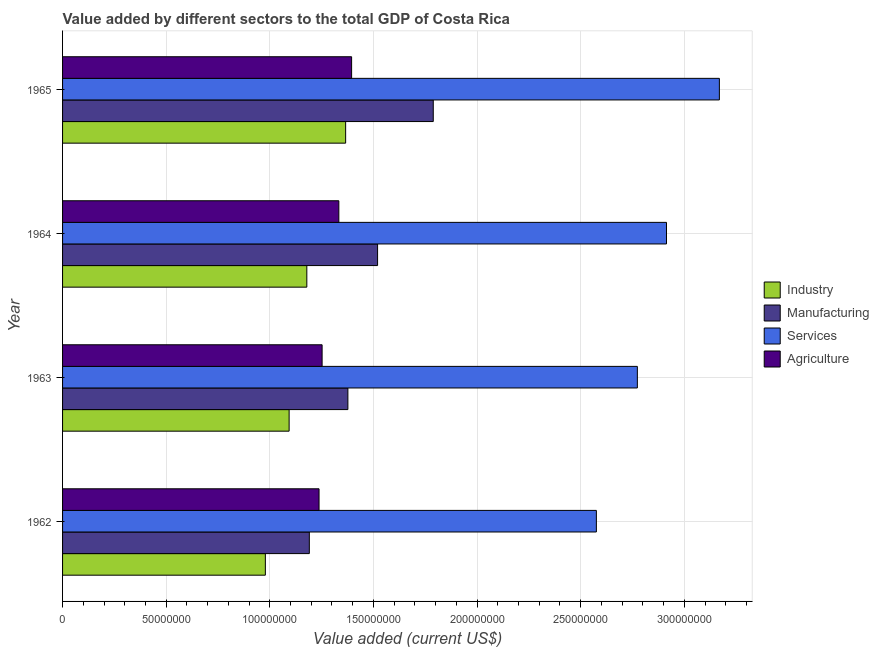How many different coloured bars are there?
Give a very brief answer. 4. Are the number of bars per tick equal to the number of legend labels?
Provide a short and direct response. Yes. How many bars are there on the 2nd tick from the top?
Offer a terse response. 4. How many bars are there on the 1st tick from the bottom?
Ensure brevity in your answer.  4. What is the label of the 4th group of bars from the top?
Offer a very short reply. 1962. What is the value added by agricultural sector in 1965?
Make the answer very short. 1.39e+08. Across all years, what is the maximum value added by services sector?
Offer a terse response. 3.17e+08. Across all years, what is the minimum value added by industrial sector?
Offer a terse response. 9.78e+07. In which year was the value added by services sector maximum?
Offer a very short reply. 1965. What is the total value added by industrial sector in the graph?
Offer a terse response. 4.62e+08. What is the difference between the value added by agricultural sector in 1963 and that in 1965?
Offer a very short reply. -1.42e+07. What is the difference between the value added by services sector in 1964 and the value added by agricultural sector in 1962?
Keep it short and to the point. 1.68e+08. What is the average value added by manufacturing sector per year?
Offer a terse response. 1.47e+08. In the year 1963, what is the difference between the value added by agricultural sector and value added by industrial sector?
Your answer should be very brief. 1.59e+07. What is the ratio of the value added by services sector in 1963 to that in 1964?
Keep it short and to the point. 0.95. Is the value added by industrial sector in 1963 less than that in 1964?
Keep it short and to the point. Yes. What is the difference between the highest and the second highest value added by agricultural sector?
Ensure brevity in your answer.  6.17e+06. What is the difference between the highest and the lowest value added by manufacturing sector?
Offer a terse response. 5.98e+07. Is the sum of the value added by industrial sector in 1962 and 1964 greater than the maximum value added by manufacturing sector across all years?
Your answer should be compact. Yes. Is it the case that in every year, the sum of the value added by manufacturing sector and value added by services sector is greater than the sum of value added by industrial sector and value added by agricultural sector?
Provide a short and direct response. No. What does the 4th bar from the top in 1965 represents?
Your answer should be compact. Industry. What does the 4th bar from the bottom in 1965 represents?
Offer a terse response. Agriculture. How many bars are there?
Provide a succinct answer. 16. How many years are there in the graph?
Provide a short and direct response. 4. What is the difference between two consecutive major ticks on the X-axis?
Make the answer very short. 5.00e+07. Are the values on the major ticks of X-axis written in scientific E-notation?
Your answer should be compact. No. Does the graph contain grids?
Provide a succinct answer. Yes. What is the title of the graph?
Your answer should be compact. Value added by different sectors to the total GDP of Costa Rica. Does "Manufacturing" appear as one of the legend labels in the graph?
Keep it short and to the point. Yes. What is the label or title of the X-axis?
Make the answer very short. Value added (current US$). What is the label or title of the Y-axis?
Your response must be concise. Year. What is the Value added (current US$) of Industry in 1962?
Provide a short and direct response. 9.78e+07. What is the Value added (current US$) in Manufacturing in 1962?
Ensure brevity in your answer.  1.19e+08. What is the Value added (current US$) of Services in 1962?
Keep it short and to the point. 2.58e+08. What is the Value added (current US$) of Agriculture in 1962?
Offer a very short reply. 1.24e+08. What is the Value added (current US$) in Industry in 1963?
Give a very brief answer. 1.09e+08. What is the Value added (current US$) in Manufacturing in 1963?
Your response must be concise. 1.38e+08. What is the Value added (current US$) of Services in 1963?
Your answer should be very brief. 2.77e+08. What is the Value added (current US$) in Agriculture in 1963?
Offer a very short reply. 1.25e+08. What is the Value added (current US$) of Industry in 1964?
Provide a short and direct response. 1.18e+08. What is the Value added (current US$) in Manufacturing in 1964?
Offer a very short reply. 1.52e+08. What is the Value added (current US$) of Services in 1964?
Keep it short and to the point. 2.91e+08. What is the Value added (current US$) in Agriculture in 1964?
Make the answer very short. 1.33e+08. What is the Value added (current US$) in Industry in 1965?
Make the answer very short. 1.37e+08. What is the Value added (current US$) in Manufacturing in 1965?
Make the answer very short. 1.79e+08. What is the Value added (current US$) in Services in 1965?
Make the answer very short. 3.17e+08. What is the Value added (current US$) in Agriculture in 1965?
Offer a terse response. 1.39e+08. Across all years, what is the maximum Value added (current US$) in Industry?
Your answer should be compact. 1.37e+08. Across all years, what is the maximum Value added (current US$) of Manufacturing?
Offer a very short reply. 1.79e+08. Across all years, what is the maximum Value added (current US$) of Services?
Provide a short and direct response. 3.17e+08. Across all years, what is the maximum Value added (current US$) in Agriculture?
Your answer should be very brief. 1.39e+08. Across all years, what is the minimum Value added (current US$) in Industry?
Provide a succinct answer. 9.78e+07. Across all years, what is the minimum Value added (current US$) in Manufacturing?
Make the answer very short. 1.19e+08. Across all years, what is the minimum Value added (current US$) in Services?
Provide a succinct answer. 2.58e+08. Across all years, what is the minimum Value added (current US$) of Agriculture?
Make the answer very short. 1.24e+08. What is the total Value added (current US$) in Industry in the graph?
Your answer should be compact. 4.62e+08. What is the total Value added (current US$) in Manufacturing in the graph?
Your response must be concise. 5.88e+08. What is the total Value added (current US$) in Services in the graph?
Provide a short and direct response. 1.14e+09. What is the total Value added (current US$) of Agriculture in the graph?
Give a very brief answer. 5.22e+08. What is the difference between the Value added (current US$) of Industry in 1962 and that in 1963?
Make the answer very short. -1.15e+07. What is the difference between the Value added (current US$) in Manufacturing in 1962 and that in 1963?
Your answer should be very brief. -1.86e+07. What is the difference between the Value added (current US$) of Services in 1962 and that in 1963?
Provide a short and direct response. -1.98e+07. What is the difference between the Value added (current US$) of Agriculture in 1962 and that in 1963?
Your answer should be very brief. -1.47e+06. What is the difference between the Value added (current US$) in Industry in 1962 and that in 1964?
Your response must be concise. -2.00e+07. What is the difference between the Value added (current US$) of Manufacturing in 1962 and that in 1964?
Provide a succinct answer. -3.29e+07. What is the difference between the Value added (current US$) in Services in 1962 and that in 1964?
Ensure brevity in your answer.  -3.38e+07. What is the difference between the Value added (current US$) of Agriculture in 1962 and that in 1964?
Make the answer very short. -9.55e+06. What is the difference between the Value added (current US$) in Industry in 1962 and that in 1965?
Make the answer very short. -3.87e+07. What is the difference between the Value added (current US$) of Manufacturing in 1962 and that in 1965?
Your response must be concise. -5.98e+07. What is the difference between the Value added (current US$) of Services in 1962 and that in 1965?
Make the answer very short. -5.93e+07. What is the difference between the Value added (current US$) in Agriculture in 1962 and that in 1965?
Your answer should be very brief. -1.57e+07. What is the difference between the Value added (current US$) in Industry in 1963 and that in 1964?
Give a very brief answer. -8.54e+06. What is the difference between the Value added (current US$) of Manufacturing in 1963 and that in 1964?
Your response must be concise. -1.43e+07. What is the difference between the Value added (current US$) in Services in 1963 and that in 1964?
Your response must be concise. -1.41e+07. What is the difference between the Value added (current US$) in Agriculture in 1963 and that in 1964?
Give a very brief answer. -8.08e+06. What is the difference between the Value added (current US$) of Industry in 1963 and that in 1965?
Make the answer very short. -2.73e+07. What is the difference between the Value added (current US$) of Manufacturing in 1963 and that in 1965?
Ensure brevity in your answer.  -4.12e+07. What is the difference between the Value added (current US$) of Services in 1963 and that in 1965?
Keep it short and to the point. -3.96e+07. What is the difference between the Value added (current US$) in Agriculture in 1963 and that in 1965?
Give a very brief answer. -1.42e+07. What is the difference between the Value added (current US$) of Industry in 1964 and that in 1965?
Provide a succinct answer. -1.87e+07. What is the difference between the Value added (current US$) in Manufacturing in 1964 and that in 1965?
Give a very brief answer. -2.69e+07. What is the difference between the Value added (current US$) in Services in 1964 and that in 1965?
Offer a terse response. -2.55e+07. What is the difference between the Value added (current US$) of Agriculture in 1964 and that in 1965?
Your answer should be compact. -6.17e+06. What is the difference between the Value added (current US$) of Industry in 1962 and the Value added (current US$) of Manufacturing in 1963?
Your response must be concise. -3.98e+07. What is the difference between the Value added (current US$) of Industry in 1962 and the Value added (current US$) of Services in 1963?
Offer a terse response. -1.80e+08. What is the difference between the Value added (current US$) of Industry in 1962 and the Value added (current US$) of Agriculture in 1963?
Give a very brief answer. -2.74e+07. What is the difference between the Value added (current US$) of Manufacturing in 1962 and the Value added (current US$) of Services in 1963?
Ensure brevity in your answer.  -1.58e+08. What is the difference between the Value added (current US$) of Manufacturing in 1962 and the Value added (current US$) of Agriculture in 1963?
Provide a short and direct response. -6.17e+06. What is the difference between the Value added (current US$) in Services in 1962 and the Value added (current US$) in Agriculture in 1963?
Keep it short and to the point. 1.32e+08. What is the difference between the Value added (current US$) in Industry in 1962 and the Value added (current US$) in Manufacturing in 1964?
Your answer should be very brief. -5.42e+07. What is the difference between the Value added (current US$) in Industry in 1962 and the Value added (current US$) in Services in 1964?
Your answer should be compact. -1.94e+08. What is the difference between the Value added (current US$) in Industry in 1962 and the Value added (current US$) in Agriculture in 1964?
Your answer should be compact. -3.55e+07. What is the difference between the Value added (current US$) in Manufacturing in 1962 and the Value added (current US$) in Services in 1964?
Provide a short and direct response. -1.72e+08. What is the difference between the Value added (current US$) in Manufacturing in 1962 and the Value added (current US$) in Agriculture in 1964?
Ensure brevity in your answer.  -1.42e+07. What is the difference between the Value added (current US$) of Services in 1962 and the Value added (current US$) of Agriculture in 1964?
Offer a very short reply. 1.24e+08. What is the difference between the Value added (current US$) of Industry in 1962 and the Value added (current US$) of Manufacturing in 1965?
Give a very brief answer. -8.10e+07. What is the difference between the Value added (current US$) in Industry in 1962 and the Value added (current US$) in Services in 1965?
Provide a succinct answer. -2.19e+08. What is the difference between the Value added (current US$) in Industry in 1962 and the Value added (current US$) in Agriculture in 1965?
Offer a very short reply. -4.16e+07. What is the difference between the Value added (current US$) of Manufacturing in 1962 and the Value added (current US$) of Services in 1965?
Provide a short and direct response. -1.98e+08. What is the difference between the Value added (current US$) in Manufacturing in 1962 and the Value added (current US$) in Agriculture in 1965?
Provide a succinct answer. -2.04e+07. What is the difference between the Value added (current US$) of Services in 1962 and the Value added (current US$) of Agriculture in 1965?
Your answer should be very brief. 1.18e+08. What is the difference between the Value added (current US$) in Industry in 1963 and the Value added (current US$) in Manufacturing in 1964?
Keep it short and to the point. -4.27e+07. What is the difference between the Value added (current US$) of Industry in 1963 and the Value added (current US$) of Services in 1964?
Provide a short and direct response. -1.82e+08. What is the difference between the Value added (current US$) of Industry in 1963 and the Value added (current US$) of Agriculture in 1964?
Ensure brevity in your answer.  -2.40e+07. What is the difference between the Value added (current US$) in Manufacturing in 1963 and the Value added (current US$) in Services in 1964?
Give a very brief answer. -1.54e+08. What is the difference between the Value added (current US$) of Manufacturing in 1963 and the Value added (current US$) of Agriculture in 1964?
Provide a short and direct response. 4.37e+06. What is the difference between the Value added (current US$) in Services in 1963 and the Value added (current US$) in Agriculture in 1964?
Make the answer very short. 1.44e+08. What is the difference between the Value added (current US$) of Industry in 1963 and the Value added (current US$) of Manufacturing in 1965?
Your answer should be very brief. -6.95e+07. What is the difference between the Value added (current US$) in Industry in 1963 and the Value added (current US$) in Services in 1965?
Offer a very short reply. -2.08e+08. What is the difference between the Value added (current US$) in Industry in 1963 and the Value added (current US$) in Agriculture in 1965?
Make the answer very short. -3.01e+07. What is the difference between the Value added (current US$) of Manufacturing in 1963 and the Value added (current US$) of Services in 1965?
Give a very brief answer. -1.79e+08. What is the difference between the Value added (current US$) in Manufacturing in 1963 and the Value added (current US$) in Agriculture in 1965?
Offer a very short reply. -1.80e+06. What is the difference between the Value added (current US$) of Services in 1963 and the Value added (current US$) of Agriculture in 1965?
Ensure brevity in your answer.  1.38e+08. What is the difference between the Value added (current US$) in Industry in 1964 and the Value added (current US$) in Manufacturing in 1965?
Your answer should be compact. -6.10e+07. What is the difference between the Value added (current US$) of Industry in 1964 and the Value added (current US$) of Services in 1965?
Your answer should be compact. -1.99e+08. What is the difference between the Value added (current US$) of Industry in 1964 and the Value added (current US$) of Agriculture in 1965?
Make the answer very short. -2.16e+07. What is the difference between the Value added (current US$) of Manufacturing in 1964 and the Value added (current US$) of Services in 1965?
Your answer should be compact. -1.65e+08. What is the difference between the Value added (current US$) in Manufacturing in 1964 and the Value added (current US$) in Agriculture in 1965?
Offer a very short reply. 1.25e+07. What is the difference between the Value added (current US$) of Services in 1964 and the Value added (current US$) of Agriculture in 1965?
Give a very brief answer. 1.52e+08. What is the average Value added (current US$) in Industry per year?
Your response must be concise. 1.15e+08. What is the average Value added (current US$) of Manufacturing per year?
Your answer should be very brief. 1.47e+08. What is the average Value added (current US$) of Services per year?
Give a very brief answer. 2.86e+08. What is the average Value added (current US$) in Agriculture per year?
Offer a very short reply. 1.30e+08. In the year 1962, what is the difference between the Value added (current US$) in Industry and Value added (current US$) in Manufacturing?
Keep it short and to the point. -2.12e+07. In the year 1962, what is the difference between the Value added (current US$) of Industry and Value added (current US$) of Services?
Provide a short and direct response. -1.60e+08. In the year 1962, what is the difference between the Value added (current US$) of Industry and Value added (current US$) of Agriculture?
Ensure brevity in your answer.  -2.59e+07. In the year 1962, what is the difference between the Value added (current US$) of Manufacturing and Value added (current US$) of Services?
Your answer should be compact. -1.39e+08. In the year 1962, what is the difference between the Value added (current US$) of Manufacturing and Value added (current US$) of Agriculture?
Offer a very short reply. -4.69e+06. In the year 1962, what is the difference between the Value added (current US$) in Services and Value added (current US$) in Agriculture?
Your response must be concise. 1.34e+08. In the year 1963, what is the difference between the Value added (current US$) of Industry and Value added (current US$) of Manufacturing?
Make the answer very short. -2.84e+07. In the year 1963, what is the difference between the Value added (current US$) in Industry and Value added (current US$) in Services?
Keep it short and to the point. -1.68e+08. In the year 1963, what is the difference between the Value added (current US$) in Industry and Value added (current US$) in Agriculture?
Make the answer very short. -1.59e+07. In the year 1963, what is the difference between the Value added (current US$) of Manufacturing and Value added (current US$) of Services?
Provide a succinct answer. -1.40e+08. In the year 1963, what is the difference between the Value added (current US$) in Manufacturing and Value added (current US$) in Agriculture?
Your response must be concise. 1.24e+07. In the year 1963, what is the difference between the Value added (current US$) in Services and Value added (current US$) in Agriculture?
Provide a short and direct response. 1.52e+08. In the year 1964, what is the difference between the Value added (current US$) in Industry and Value added (current US$) in Manufacturing?
Your answer should be very brief. -3.41e+07. In the year 1964, what is the difference between the Value added (current US$) of Industry and Value added (current US$) of Services?
Offer a very short reply. -1.74e+08. In the year 1964, what is the difference between the Value added (current US$) in Industry and Value added (current US$) in Agriculture?
Your response must be concise. -1.54e+07. In the year 1964, what is the difference between the Value added (current US$) of Manufacturing and Value added (current US$) of Services?
Your answer should be compact. -1.39e+08. In the year 1964, what is the difference between the Value added (current US$) in Manufacturing and Value added (current US$) in Agriculture?
Provide a short and direct response. 1.87e+07. In the year 1964, what is the difference between the Value added (current US$) of Services and Value added (current US$) of Agriculture?
Keep it short and to the point. 1.58e+08. In the year 1965, what is the difference between the Value added (current US$) of Industry and Value added (current US$) of Manufacturing?
Make the answer very short. -4.23e+07. In the year 1965, what is the difference between the Value added (current US$) of Industry and Value added (current US$) of Services?
Give a very brief answer. -1.80e+08. In the year 1965, what is the difference between the Value added (current US$) in Industry and Value added (current US$) in Agriculture?
Offer a terse response. -2.88e+06. In the year 1965, what is the difference between the Value added (current US$) of Manufacturing and Value added (current US$) of Services?
Give a very brief answer. -1.38e+08. In the year 1965, what is the difference between the Value added (current US$) in Manufacturing and Value added (current US$) in Agriculture?
Your answer should be very brief. 3.94e+07. In the year 1965, what is the difference between the Value added (current US$) of Services and Value added (current US$) of Agriculture?
Provide a short and direct response. 1.77e+08. What is the ratio of the Value added (current US$) of Industry in 1962 to that in 1963?
Your response must be concise. 0.9. What is the ratio of the Value added (current US$) in Manufacturing in 1962 to that in 1963?
Provide a succinct answer. 0.86. What is the ratio of the Value added (current US$) in Services in 1962 to that in 1963?
Provide a succinct answer. 0.93. What is the ratio of the Value added (current US$) of Agriculture in 1962 to that in 1963?
Your answer should be very brief. 0.99. What is the ratio of the Value added (current US$) in Industry in 1962 to that in 1964?
Provide a short and direct response. 0.83. What is the ratio of the Value added (current US$) in Manufacturing in 1962 to that in 1964?
Give a very brief answer. 0.78. What is the ratio of the Value added (current US$) of Services in 1962 to that in 1964?
Offer a very short reply. 0.88. What is the ratio of the Value added (current US$) of Agriculture in 1962 to that in 1964?
Provide a succinct answer. 0.93. What is the ratio of the Value added (current US$) in Industry in 1962 to that in 1965?
Provide a short and direct response. 0.72. What is the ratio of the Value added (current US$) of Manufacturing in 1962 to that in 1965?
Give a very brief answer. 0.67. What is the ratio of the Value added (current US$) in Services in 1962 to that in 1965?
Make the answer very short. 0.81. What is the ratio of the Value added (current US$) of Agriculture in 1962 to that in 1965?
Offer a terse response. 0.89. What is the ratio of the Value added (current US$) in Industry in 1963 to that in 1964?
Keep it short and to the point. 0.93. What is the ratio of the Value added (current US$) of Manufacturing in 1963 to that in 1964?
Your answer should be compact. 0.91. What is the ratio of the Value added (current US$) in Services in 1963 to that in 1964?
Ensure brevity in your answer.  0.95. What is the ratio of the Value added (current US$) of Agriculture in 1963 to that in 1964?
Your answer should be very brief. 0.94. What is the ratio of the Value added (current US$) in Industry in 1963 to that in 1965?
Offer a very short reply. 0.8. What is the ratio of the Value added (current US$) in Manufacturing in 1963 to that in 1965?
Offer a terse response. 0.77. What is the ratio of the Value added (current US$) of Services in 1963 to that in 1965?
Provide a short and direct response. 0.88. What is the ratio of the Value added (current US$) in Agriculture in 1963 to that in 1965?
Provide a short and direct response. 0.9. What is the ratio of the Value added (current US$) in Industry in 1964 to that in 1965?
Your answer should be very brief. 0.86. What is the ratio of the Value added (current US$) of Manufacturing in 1964 to that in 1965?
Your response must be concise. 0.85. What is the ratio of the Value added (current US$) of Services in 1964 to that in 1965?
Your answer should be very brief. 0.92. What is the ratio of the Value added (current US$) of Agriculture in 1964 to that in 1965?
Ensure brevity in your answer.  0.96. What is the difference between the highest and the second highest Value added (current US$) of Industry?
Offer a terse response. 1.87e+07. What is the difference between the highest and the second highest Value added (current US$) in Manufacturing?
Keep it short and to the point. 2.69e+07. What is the difference between the highest and the second highest Value added (current US$) of Services?
Keep it short and to the point. 2.55e+07. What is the difference between the highest and the second highest Value added (current US$) of Agriculture?
Your response must be concise. 6.17e+06. What is the difference between the highest and the lowest Value added (current US$) of Industry?
Ensure brevity in your answer.  3.87e+07. What is the difference between the highest and the lowest Value added (current US$) of Manufacturing?
Your response must be concise. 5.98e+07. What is the difference between the highest and the lowest Value added (current US$) in Services?
Provide a succinct answer. 5.93e+07. What is the difference between the highest and the lowest Value added (current US$) of Agriculture?
Provide a succinct answer. 1.57e+07. 